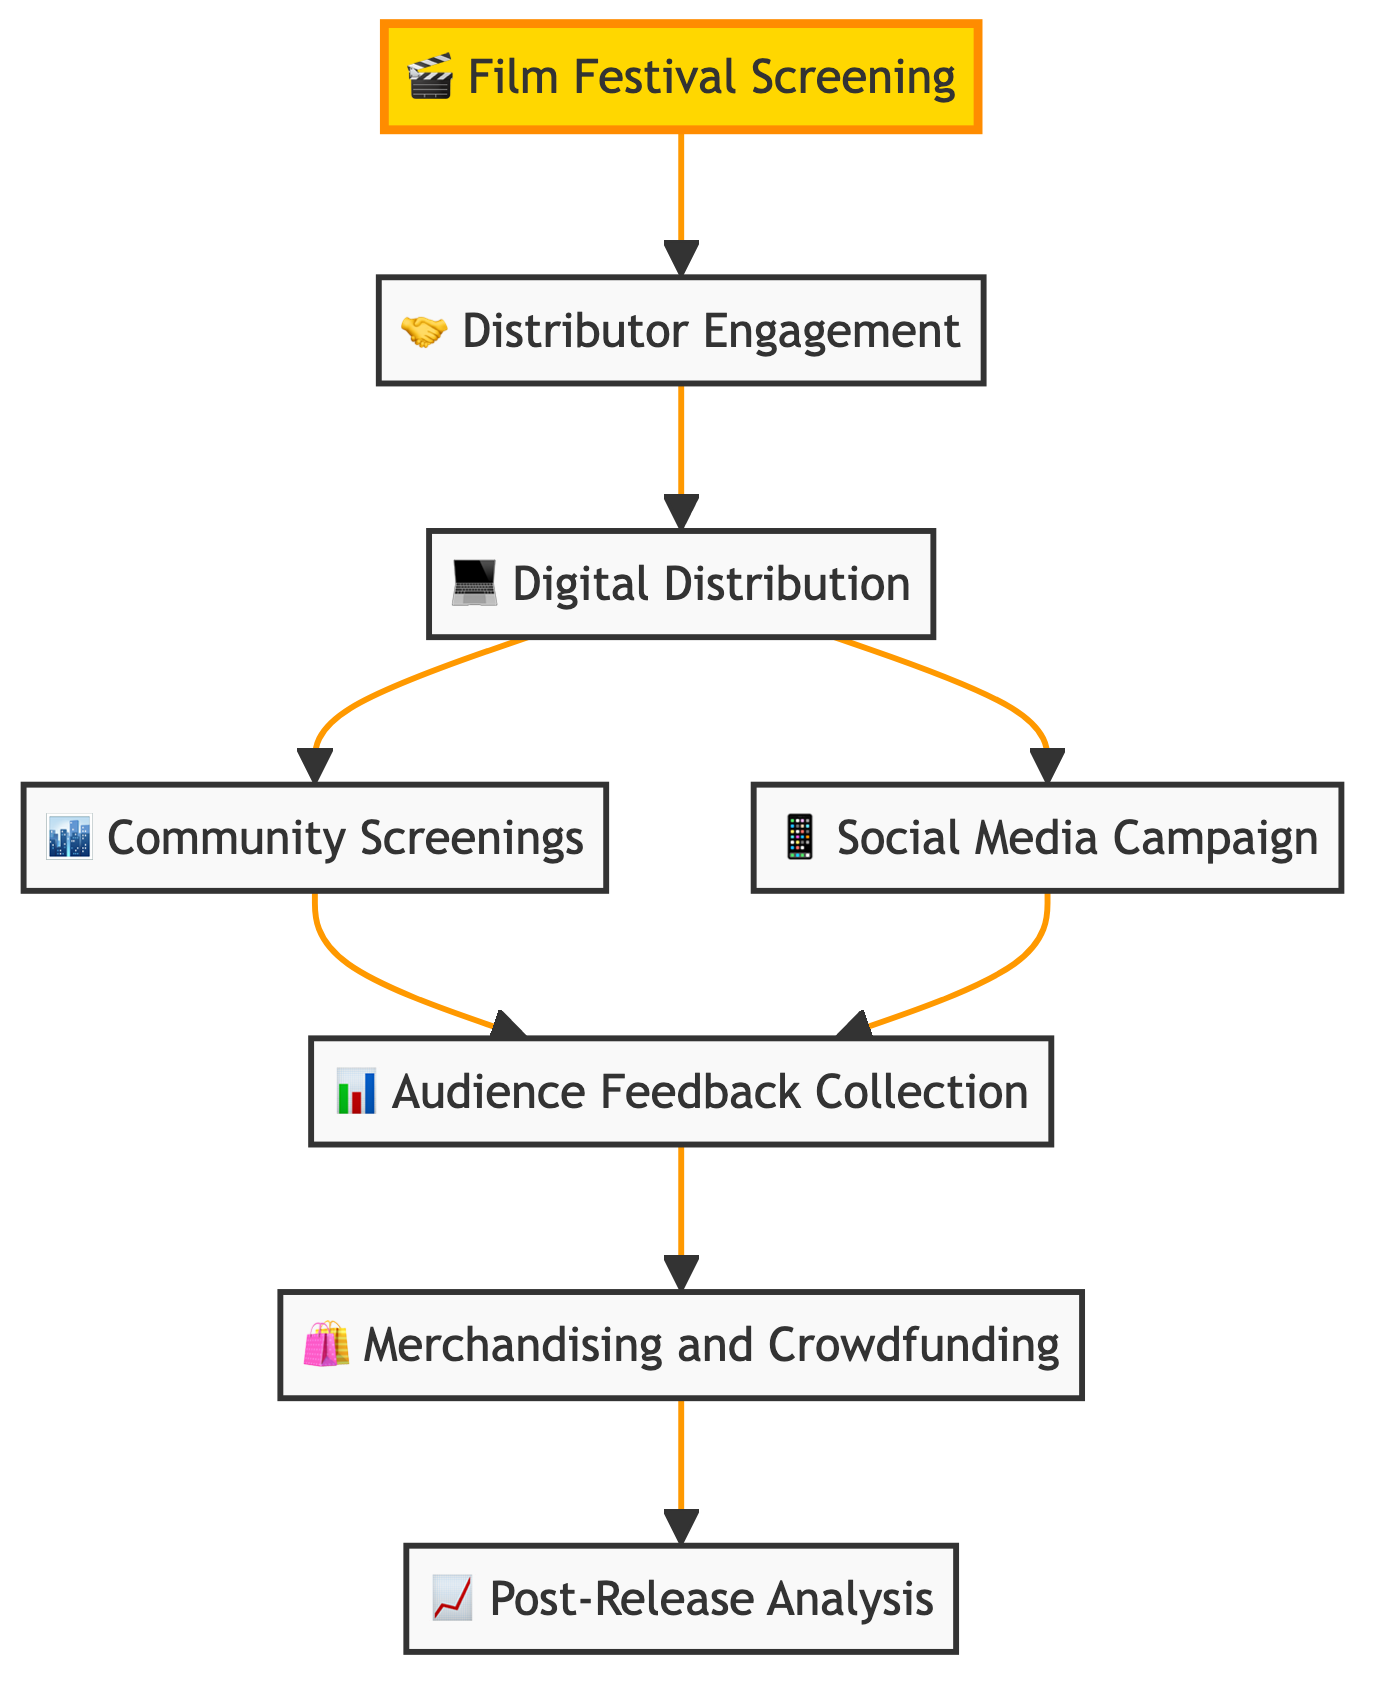What is the first step in the independent film distribution strategy? The first step is "Film Festival Screening," as indicated by the flowchart showing it as the starting node in the process.
Answer: Film Festival Screening How many main activities are there in the distribution strategy? By counting the nodes in the flowchart, there are eight main activities outlined in the strategy.
Answer: Eight What is the relationship between "Digital Distribution" and "Community Screenings"? "Digital Distribution" leads to both "Community Screenings" and "Social Media Campaign," which indicates there are multiple pathways after digital release to engage audiences.
Answer: No direct relationship Which step comes immediately after "Distributor Engagement"? "Digital Distribution" follows "Distributor Engagement" directly in the flowchart, indicating that distribution deals lead to a digital release of the film.
Answer: Digital Distribution What activity follows "Audience Feedback Collection"? After collecting audience feedback, the next activity is "Merchandising and Crowdfunding," showing a continuation of audience engagement strategies.
Answer: Merchandising and Crowdfunding Which two activities are connected to "Social Media Campaign"? "Social Media Campaign" connects to both "Audience Feedback Collection" and "Digital Distribution," indicating that social media is an important part of marketing and feedback processes.
Answer: Audience Feedback Collection and Digital Distribution Which node is a highlight in the diagram and what does it signify? The highlighted node is "Film Festival Screening," signifying its importance as the starting point to attract distributors and generate buzz for the film.
Answer: Film Festival Screening What does the "Post-Release Analysis" step involve? This step involves evaluating film performance using various metrics, as indicated by its description in the flowchart, to inform future strategies in distribution.
Answer: Evaluating film performance How does "Merchandising and Crowdfunding" support audience engagement? "Merchandising and Crowdfunding" allows for direct audience interaction and support, as it creates avenues for fans to be involved and invested in the film beyond just viewing.
Answer: Direct audience interaction 